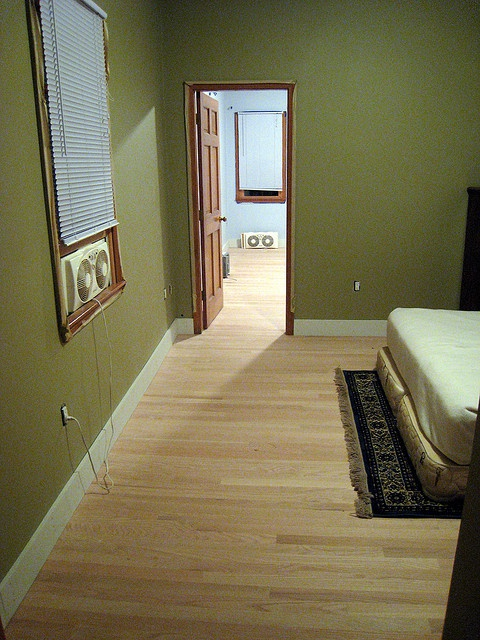Describe the objects in this image and their specific colors. I can see a bed in gray, black, olive, and beige tones in this image. 